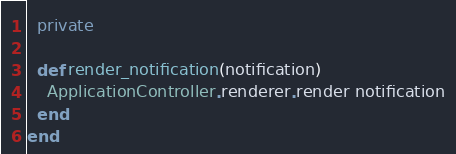<code> <loc_0><loc_0><loc_500><loc_500><_Ruby_>
  private

  def render_notification(notification)
    ApplicationController.renderer.render notification
  end
end
</code> 